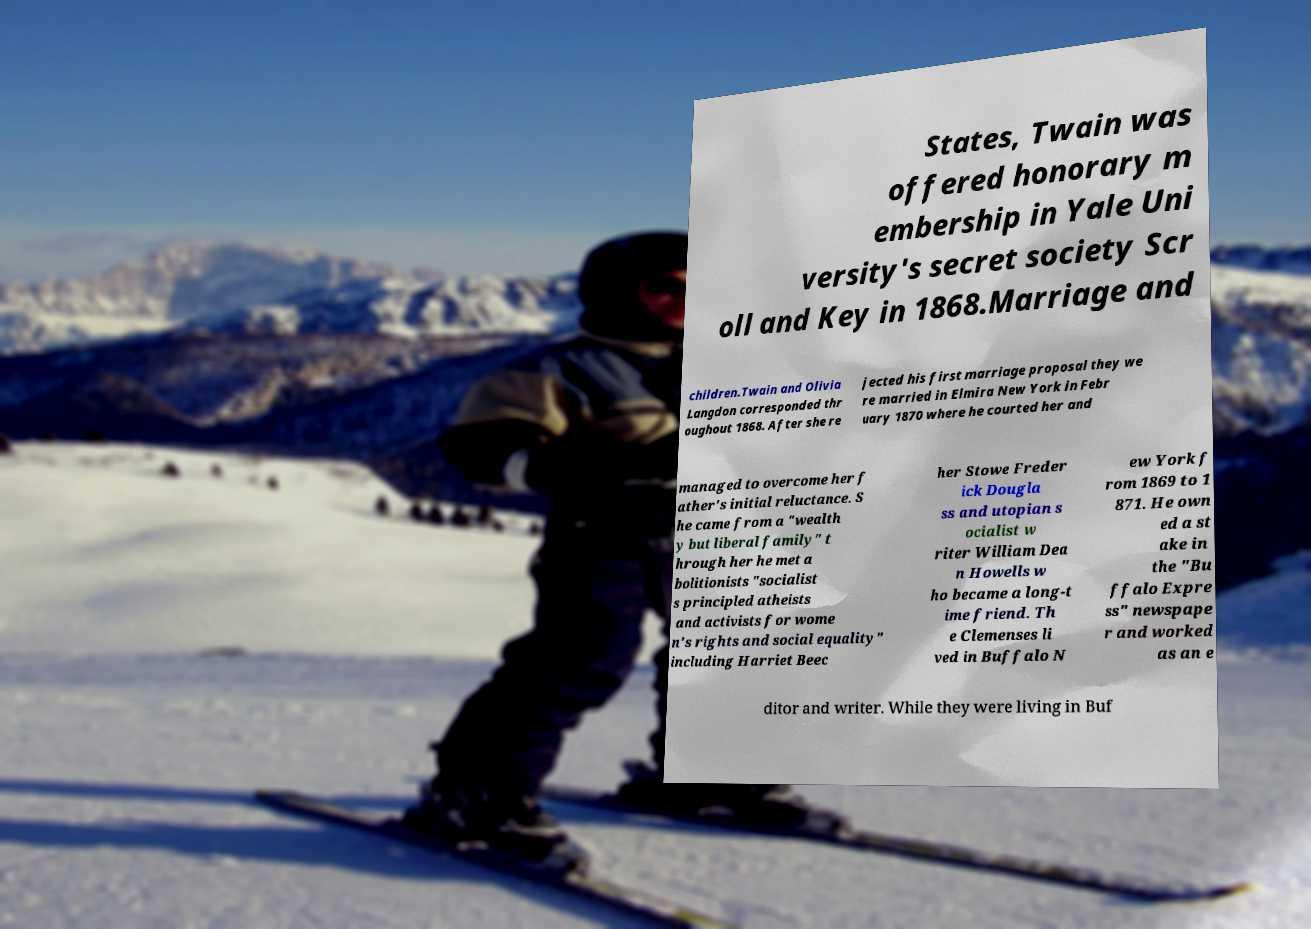Can you accurately transcribe the text from the provided image for me? States, Twain was offered honorary m embership in Yale Uni versity's secret society Scr oll and Key in 1868.Marriage and children.Twain and Olivia Langdon corresponded thr oughout 1868. After she re jected his first marriage proposal they we re married in Elmira New York in Febr uary 1870 where he courted her and managed to overcome her f ather's initial reluctance. S he came from a "wealth y but liberal family" t hrough her he met a bolitionists "socialist s principled atheists and activists for wome n's rights and social equality" including Harriet Beec her Stowe Freder ick Dougla ss and utopian s ocialist w riter William Dea n Howells w ho became a long-t ime friend. Th e Clemenses li ved in Buffalo N ew York f rom 1869 to 1 871. He own ed a st ake in the "Bu ffalo Expre ss" newspape r and worked as an e ditor and writer. While they were living in Buf 